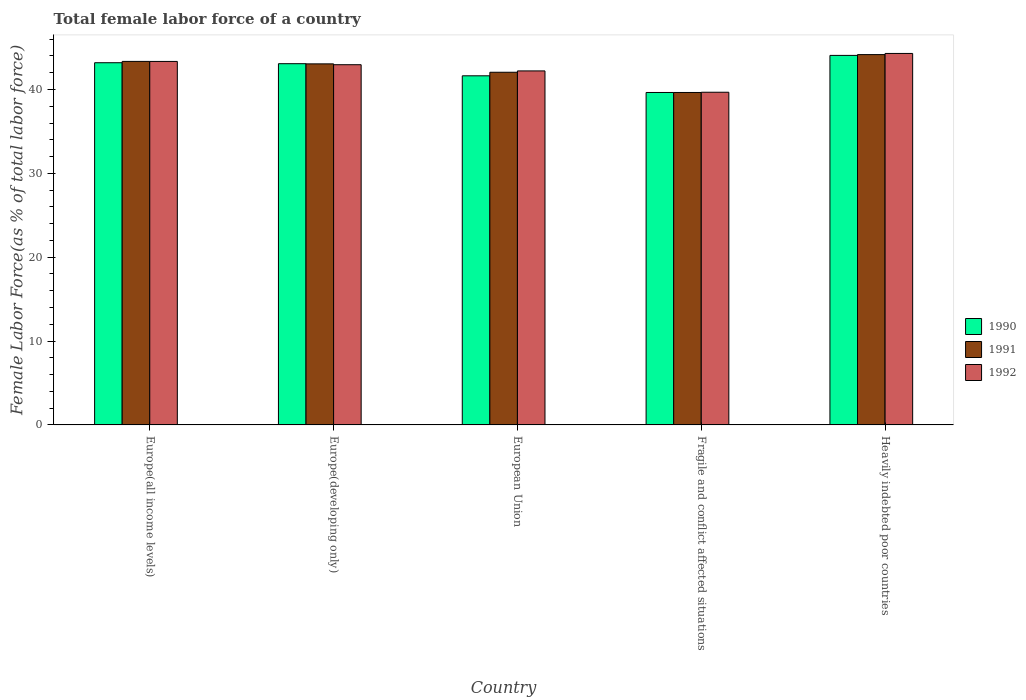How many groups of bars are there?
Give a very brief answer. 5. Are the number of bars per tick equal to the number of legend labels?
Offer a terse response. Yes. Are the number of bars on each tick of the X-axis equal?
Give a very brief answer. Yes. What is the label of the 5th group of bars from the left?
Ensure brevity in your answer.  Heavily indebted poor countries. What is the percentage of female labor force in 1990 in Fragile and conflict affected situations?
Your answer should be very brief. 39.65. Across all countries, what is the maximum percentage of female labor force in 1992?
Make the answer very short. 44.3. Across all countries, what is the minimum percentage of female labor force in 1992?
Ensure brevity in your answer.  39.67. In which country was the percentage of female labor force in 1992 maximum?
Offer a terse response. Heavily indebted poor countries. In which country was the percentage of female labor force in 1990 minimum?
Your answer should be very brief. Fragile and conflict affected situations. What is the total percentage of female labor force in 1990 in the graph?
Give a very brief answer. 211.62. What is the difference between the percentage of female labor force in 1990 in Fragile and conflict affected situations and that in Heavily indebted poor countries?
Keep it short and to the point. -4.42. What is the difference between the percentage of female labor force in 1992 in Fragile and conflict affected situations and the percentage of female labor force in 1990 in Europe(developing only)?
Keep it short and to the point. -3.41. What is the average percentage of female labor force in 1992 per country?
Your answer should be compact. 42.5. What is the difference between the percentage of female labor force of/in 1992 and percentage of female labor force of/in 1991 in European Union?
Provide a short and direct response. 0.16. What is the ratio of the percentage of female labor force in 1991 in Europe(developing only) to that in European Union?
Your answer should be compact. 1.02. Is the percentage of female labor force in 1990 in Europe(developing only) less than that in European Union?
Keep it short and to the point. No. Is the difference between the percentage of female labor force in 1992 in Europe(all income levels) and European Union greater than the difference between the percentage of female labor force in 1991 in Europe(all income levels) and European Union?
Offer a very short reply. No. What is the difference between the highest and the second highest percentage of female labor force in 1990?
Your answer should be compact. -0.12. What is the difference between the highest and the lowest percentage of female labor force in 1990?
Offer a very short reply. 4.42. Is the sum of the percentage of female labor force in 1991 in Europe(developing only) and European Union greater than the maximum percentage of female labor force in 1990 across all countries?
Make the answer very short. Yes. What does the 2nd bar from the right in Fragile and conflict affected situations represents?
Your answer should be compact. 1991. How many bars are there?
Give a very brief answer. 15. Are all the bars in the graph horizontal?
Provide a short and direct response. No. What is the difference between two consecutive major ticks on the Y-axis?
Give a very brief answer. 10. Does the graph contain any zero values?
Provide a short and direct response. No. Where does the legend appear in the graph?
Offer a terse response. Center right. How many legend labels are there?
Offer a very short reply. 3. How are the legend labels stacked?
Make the answer very short. Vertical. What is the title of the graph?
Provide a short and direct response. Total female labor force of a country. Does "1998" appear as one of the legend labels in the graph?
Your response must be concise. No. What is the label or title of the Y-axis?
Offer a very short reply. Female Labor Force(as % of total labor force). What is the Female Labor Force(as % of total labor force) of 1990 in Europe(all income levels)?
Your answer should be very brief. 43.2. What is the Female Labor Force(as % of total labor force) in 1991 in Europe(all income levels)?
Make the answer very short. 43.35. What is the Female Labor Force(as % of total labor force) in 1992 in Europe(all income levels)?
Provide a short and direct response. 43.35. What is the Female Labor Force(as % of total labor force) in 1990 in Europe(developing only)?
Your answer should be very brief. 43.08. What is the Female Labor Force(as % of total labor force) of 1991 in Europe(developing only)?
Offer a very short reply. 43.06. What is the Female Labor Force(as % of total labor force) of 1992 in Europe(developing only)?
Ensure brevity in your answer.  42.96. What is the Female Labor Force(as % of total labor force) of 1990 in European Union?
Provide a succinct answer. 41.63. What is the Female Labor Force(as % of total labor force) in 1991 in European Union?
Provide a succinct answer. 42.06. What is the Female Labor Force(as % of total labor force) of 1992 in European Union?
Offer a terse response. 42.22. What is the Female Labor Force(as % of total labor force) of 1990 in Fragile and conflict affected situations?
Offer a terse response. 39.65. What is the Female Labor Force(as % of total labor force) in 1991 in Fragile and conflict affected situations?
Your response must be concise. 39.65. What is the Female Labor Force(as % of total labor force) of 1992 in Fragile and conflict affected situations?
Your response must be concise. 39.67. What is the Female Labor Force(as % of total labor force) in 1990 in Heavily indebted poor countries?
Provide a succinct answer. 44.07. What is the Female Labor Force(as % of total labor force) of 1991 in Heavily indebted poor countries?
Make the answer very short. 44.16. What is the Female Labor Force(as % of total labor force) of 1992 in Heavily indebted poor countries?
Your answer should be very brief. 44.3. Across all countries, what is the maximum Female Labor Force(as % of total labor force) in 1990?
Keep it short and to the point. 44.07. Across all countries, what is the maximum Female Labor Force(as % of total labor force) in 1991?
Your answer should be compact. 44.16. Across all countries, what is the maximum Female Labor Force(as % of total labor force) of 1992?
Your answer should be compact. 44.3. Across all countries, what is the minimum Female Labor Force(as % of total labor force) of 1990?
Provide a short and direct response. 39.65. Across all countries, what is the minimum Female Labor Force(as % of total labor force) of 1991?
Your answer should be very brief. 39.65. Across all countries, what is the minimum Female Labor Force(as % of total labor force) in 1992?
Your answer should be very brief. 39.67. What is the total Female Labor Force(as % of total labor force) in 1990 in the graph?
Your answer should be very brief. 211.62. What is the total Female Labor Force(as % of total labor force) of 1991 in the graph?
Your response must be concise. 212.28. What is the total Female Labor Force(as % of total labor force) in 1992 in the graph?
Your response must be concise. 212.5. What is the difference between the Female Labor Force(as % of total labor force) in 1990 in Europe(all income levels) and that in Europe(developing only)?
Provide a succinct answer. 0.12. What is the difference between the Female Labor Force(as % of total labor force) of 1991 in Europe(all income levels) and that in Europe(developing only)?
Your response must be concise. 0.3. What is the difference between the Female Labor Force(as % of total labor force) of 1992 in Europe(all income levels) and that in Europe(developing only)?
Provide a short and direct response. 0.39. What is the difference between the Female Labor Force(as % of total labor force) in 1990 in Europe(all income levels) and that in European Union?
Offer a very short reply. 1.56. What is the difference between the Female Labor Force(as % of total labor force) of 1991 in Europe(all income levels) and that in European Union?
Make the answer very short. 1.3. What is the difference between the Female Labor Force(as % of total labor force) in 1992 in Europe(all income levels) and that in European Union?
Your answer should be compact. 1.13. What is the difference between the Female Labor Force(as % of total labor force) of 1990 in Europe(all income levels) and that in Fragile and conflict affected situations?
Keep it short and to the point. 3.55. What is the difference between the Female Labor Force(as % of total labor force) of 1991 in Europe(all income levels) and that in Fragile and conflict affected situations?
Your answer should be compact. 3.71. What is the difference between the Female Labor Force(as % of total labor force) of 1992 in Europe(all income levels) and that in Fragile and conflict affected situations?
Make the answer very short. 3.68. What is the difference between the Female Labor Force(as % of total labor force) of 1990 in Europe(all income levels) and that in Heavily indebted poor countries?
Your answer should be compact. -0.87. What is the difference between the Female Labor Force(as % of total labor force) in 1991 in Europe(all income levels) and that in Heavily indebted poor countries?
Keep it short and to the point. -0.81. What is the difference between the Female Labor Force(as % of total labor force) of 1992 in Europe(all income levels) and that in Heavily indebted poor countries?
Your answer should be compact. -0.95. What is the difference between the Female Labor Force(as % of total labor force) in 1990 in Europe(developing only) and that in European Union?
Keep it short and to the point. 1.45. What is the difference between the Female Labor Force(as % of total labor force) in 1992 in Europe(developing only) and that in European Union?
Your answer should be compact. 0.74. What is the difference between the Female Labor Force(as % of total labor force) of 1990 in Europe(developing only) and that in Fragile and conflict affected situations?
Ensure brevity in your answer.  3.43. What is the difference between the Female Labor Force(as % of total labor force) in 1991 in Europe(developing only) and that in Fragile and conflict affected situations?
Offer a very short reply. 3.41. What is the difference between the Female Labor Force(as % of total labor force) of 1992 in Europe(developing only) and that in Fragile and conflict affected situations?
Ensure brevity in your answer.  3.28. What is the difference between the Female Labor Force(as % of total labor force) of 1990 in Europe(developing only) and that in Heavily indebted poor countries?
Your answer should be compact. -0.99. What is the difference between the Female Labor Force(as % of total labor force) in 1991 in Europe(developing only) and that in Heavily indebted poor countries?
Your answer should be compact. -1.11. What is the difference between the Female Labor Force(as % of total labor force) of 1992 in Europe(developing only) and that in Heavily indebted poor countries?
Provide a succinct answer. -1.34. What is the difference between the Female Labor Force(as % of total labor force) in 1990 in European Union and that in Fragile and conflict affected situations?
Offer a very short reply. 1.99. What is the difference between the Female Labor Force(as % of total labor force) in 1991 in European Union and that in Fragile and conflict affected situations?
Your answer should be compact. 2.41. What is the difference between the Female Labor Force(as % of total labor force) in 1992 in European Union and that in Fragile and conflict affected situations?
Your response must be concise. 2.54. What is the difference between the Female Labor Force(as % of total labor force) in 1990 in European Union and that in Heavily indebted poor countries?
Your response must be concise. -2.43. What is the difference between the Female Labor Force(as % of total labor force) of 1991 in European Union and that in Heavily indebted poor countries?
Provide a short and direct response. -2.11. What is the difference between the Female Labor Force(as % of total labor force) of 1992 in European Union and that in Heavily indebted poor countries?
Ensure brevity in your answer.  -2.08. What is the difference between the Female Labor Force(as % of total labor force) in 1990 in Fragile and conflict affected situations and that in Heavily indebted poor countries?
Your answer should be very brief. -4.42. What is the difference between the Female Labor Force(as % of total labor force) of 1991 in Fragile and conflict affected situations and that in Heavily indebted poor countries?
Offer a terse response. -4.52. What is the difference between the Female Labor Force(as % of total labor force) of 1992 in Fragile and conflict affected situations and that in Heavily indebted poor countries?
Offer a terse response. -4.63. What is the difference between the Female Labor Force(as % of total labor force) of 1990 in Europe(all income levels) and the Female Labor Force(as % of total labor force) of 1991 in Europe(developing only)?
Your answer should be compact. 0.14. What is the difference between the Female Labor Force(as % of total labor force) of 1990 in Europe(all income levels) and the Female Labor Force(as % of total labor force) of 1992 in Europe(developing only)?
Ensure brevity in your answer.  0.24. What is the difference between the Female Labor Force(as % of total labor force) of 1991 in Europe(all income levels) and the Female Labor Force(as % of total labor force) of 1992 in Europe(developing only)?
Offer a very short reply. 0.4. What is the difference between the Female Labor Force(as % of total labor force) in 1990 in Europe(all income levels) and the Female Labor Force(as % of total labor force) in 1991 in European Union?
Provide a short and direct response. 1.14. What is the difference between the Female Labor Force(as % of total labor force) in 1990 in Europe(all income levels) and the Female Labor Force(as % of total labor force) in 1992 in European Union?
Offer a terse response. 0.98. What is the difference between the Female Labor Force(as % of total labor force) of 1991 in Europe(all income levels) and the Female Labor Force(as % of total labor force) of 1992 in European Union?
Your response must be concise. 1.13. What is the difference between the Female Labor Force(as % of total labor force) in 1990 in Europe(all income levels) and the Female Labor Force(as % of total labor force) in 1991 in Fragile and conflict affected situations?
Ensure brevity in your answer.  3.55. What is the difference between the Female Labor Force(as % of total labor force) in 1990 in Europe(all income levels) and the Female Labor Force(as % of total labor force) in 1992 in Fragile and conflict affected situations?
Offer a very short reply. 3.52. What is the difference between the Female Labor Force(as % of total labor force) in 1991 in Europe(all income levels) and the Female Labor Force(as % of total labor force) in 1992 in Fragile and conflict affected situations?
Offer a terse response. 3.68. What is the difference between the Female Labor Force(as % of total labor force) of 1990 in Europe(all income levels) and the Female Labor Force(as % of total labor force) of 1991 in Heavily indebted poor countries?
Provide a succinct answer. -0.97. What is the difference between the Female Labor Force(as % of total labor force) in 1990 in Europe(all income levels) and the Female Labor Force(as % of total labor force) in 1992 in Heavily indebted poor countries?
Offer a very short reply. -1.11. What is the difference between the Female Labor Force(as % of total labor force) in 1991 in Europe(all income levels) and the Female Labor Force(as % of total labor force) in 1992 in Heavily indebted poor countries?
Provide a short and direct response. -0.95. What is the difference between the Female Labor Force(as % of total labor force) of 1990 in Europe(developing only) and the Female Labor Force(as % of total labor force) of 1991 in European Union?
Your answer should be compact. 1.02. What is the difference between the Female Labor Force(as % of total labor force) in 1990 in Europe(developing only) and the Female Labor Force(as % of total labor force) in 1992 in European Union?
Give a very brief answer. 0.86. What is the difference between the Female Labor Force(as % of total labor force) of 1991 in Europe(developing only) and the Female Labor Force(as % of total labor force) of 1992 in European Union?
Offer a very short reply. 0.84. What is the difference between the Female Labor Force(as % of total labor force) of 1990 in Europe(developing only) and the Female Labor Force(as % of total labor force) of 1991 in Fragile and conflict affected situations?
Give a very brief answer. 3.43. What is the difference between the Female Labor Force(as % of total labor force) in 1990 in Europe(developing only) and the Female Labor Force(as % of total labor force) in 1992 in Fragile and conflict affected situations?
Ensure brevity in your answer.  3.41. What is the difference between the Female Labor Force(as % of total labor force) of 1991 in Europe(developing only) and the Female Labor Force(as % of total labor force) of 1992 in Fragile and conflict affected situations?
Make the answer very short. 3.38. What is the difference between the Female Labor Force(as % of total labor force) in 1990 in Europe(developing only) and the Female Labor Force(as % of total labor force) in 1991 in Heavily indebted poor countries?
Make the answer very short. -1.08. What is the difference between the Female Labor Force(as % of total labor force) in 1990 in Europe(developing only) and the Female Labor Force(as % of total labor force) in 1992 in Heavily indebted poor countries?
Your answer should be very brief. -1.22. What is the difference between the Female Labor Force(as % of total labor force) in 1991 in Europe(developing only) and the Female Labor Force(as % of total labor force) in 1992 in Heavily indebted poor countries?
Provide a succinct answer. -1.24. What is the difference between the Female Labor Force(as % of total labor force) in 1990 in European Union and the Female Labor Force(as % of total labor force) in 1991 in Fragile and conflict affected situations?
Ensure brevity in your answer.  1.99. What is the difference between the Female Labor Force(as % of total labor force) in 1990 in European Union and the Female Labor Force(as % of total labor force) in 1992 in Fragile and conflict affected situations?
Your answer should be compact. 1.96. What is the difference between the Female Labor Force(as % of total labor force) of 1991 in European Union and the Female Labor Force(as % of total labor force) of 1992 in Fragile and conflict affected situations?
Your response must be concise. 2.38. What is the difference between the Female Labor Force(as % of total labor force) of 1990 in European Union and the Female Labor Force(as % of total labor force) of 1991 in Heavily indebted poor countries?
Ensure brevity in your answer.  -2.53. What is the difference between the Female Labor Force(as % of total labor force) in 1990 in European Union and the Female Labor Force(as % of total labor force) in 1992 in Heavily indebted poor countries?
Your answer should be compact. -2.67. What is the difference between the Female Labor Force(as % of total labor force) in 1991 in European Union and the Female Labor Force(as % of total labor force) in 1992 in Heavily indebted poor countries?
Offer a very short reply. -2.24. What is the difference between the Female Labor Force(as % of total labor force) of 1990 in Fragile and conflict affected situations and the Female Labor Force(as % of total labor force) of 1991 in Heavily indebted poor countries?
Offer a terse response. -4.52. What is the difference between the Female Labor Force(as % of total labor force) of 1990 in Fragile and conflict affected situations and the Female Labor Force(as % of total labor force) of 1992 in Heavily indebted poor countries?
Offer a terse response. -4.66. What is the difference between the Female Labor Force(as % of total labor force) in 1991 in Fragile and conflict affected situations and the Female Labor Force(as % of total labor force) in 1992 in Heavily indebted poor countries?
Give a very brief answer. -4.65. What is the average Female Labor Force(as % of total labor force) of 1990 per country?
Offer a very short reply. 42.32. What is the average Female Labor Force(as % of total labor force) in 1991 per country?
Provide a succinct answer. 42.46. What is the average Female Labor Force(as % of total labor force) in 1992 per country?
Make the answer very short. 42.5. What is the difference between the Female Labor Force(as % of total labor force) of 1990 and Female Labor Force(as % of total labor force) of 1991 in Europe(all income levels)?
Your answer should be compact. -0.16. What is the difference between the Female Labor Force(as % of total labor force) of 1990 and Female Labor Force(as % of total labor force) of 1992 in Europe(all income levels)?
Keep it short and to the point. -0.15. What is the difference between the Female Labor Force(as % of total labor force) of 1991 and Female Labor Force(as % of total labor force) of 1992 in Europe(all income levels)?
Make the answer very short. 0. What is the difference between the Female Labor Force(as % of total labor force) of 1990 and Female Labor Force(as % of total labor force) of 1991 in Europe(developing only)?
Your response must be concise. 0.02. What is the difference between the Female Labor Force(as % of total labor force) in 1990 and Female Labor Force(as % of total labor force) in 1992 in Europe(developing only)?
Your answer should be very brief. 0.12. What is the difference between the Female Labor Force(as % of total labor force) of 1991 and Female Labor Force(as % of total labor force) of 1992 in Europe(developing only)?
Your answer should be very brief. 0.1. What is the difference between the Female Labor Force(as % of total labor force) in 1990 and Female Labor Force(as % of total labor force) in 1991 in European Union?
Provide a short and direct response. -0.42. What is the difference between the Female Labor Force(as % of total labor force) of 1990 and Female Labor Force(as % of total labor force) of 1992 in European Union?
Give a very brief answer. -0.58. What is the difference between the Female Labor Force(as % of total labor force) in 1991 and Female Labor Force(as % of total labor force) in 1992 in European Union?
Provide a succinct answer. -0.16. What is the difference between the Female Labor Force(as % of total labor force) in 1990 and Female Labor Force(as % of total labor force) in 1991 in Fragile and conflict affected situations?
Your answer should be very brief. -0. What is the difference between the Female Labor Force(as % of total labor force) in 1990 and Female Labor Force(as % of total labor force) in 1992 in Fragile and conflict affected situations?
Give a very brief answer. -0.03. What is the difference between the Female Labor Force(as % of total labor force) of 1991 and Female Labor Force(as % of total labor force) of 1992 in Fragile and conflict affected situations?
Ensure brevity in your answer.  -0.03. What is the difference between the Female Labor Force(as % of total labor force) of 1990 and Female Labor Force(as % of total labor force) of 1991 in Heavily indebted poor countries?
Offer a very short reply. -0.1. What is the difference between the Female Labor Force(as % of total labor force) in 1990 and Female Labor Force(as % of total labor force) in 1992 in Heavily indebted poor countries?
Provide a succinct answer. -0.23. What is the difference between the Female Labor Force(as % of total labor force) in 1991 and Female Labor Force(as % of total labor force) in 1992 in Heavily indebted poor countries?
Your answer should be very brief. -0.14. What is the ratio of the Female Labor Force(as % of total labor force) of 1990 in Europe(all income levels) to that in Europe(developing only)?
Ensure brevity in your answer.  1. What is the ratio of the Female Labor Force(as % of total labor force) of 1991 in Europe(all income levels) to that in Europe(developing only)?
Your answer should be compact. 1.01. What is the ratio of the Female Labor Force(as % of total labor force) of 1992 in Europe(all income levels) to that in Europe(developing only)?
Make the answer very short. 1.01. What is the ratio of the Female Labor Force(as % of total labor force) of 1990 in Europe(all income levels) to that in European Union?
Make the answer very short. 1.04. What is the ratio of the Female Labor Force(as % of total labor force) of 1991 in Europe(all income levels) to that in European Union?
Your response must be concise. 1.03. What is the ratio of the Female Labor Force(as % of total labor force) in 1992 in Europe(all income levels) to that in European Union?
Make the answer very short. 1.03. What is the ratio of the Female Labor Force(as % of total labor force) in 1990 in Europe(all income levels) to that in Fragile and conflict affected situations?
Provide a succinct answer. 1.09. What is the ratio of the Female Labor Force(as % of total labor force) in 1991 in Europe(all income levels) to that in Fragile and conflict affected situations?
Make the answer very short. 1.09. What is the ratio of the Female Labor Force(as % of total labor force) of 1992 in Europe(all income levels) to that in Fragile and conflict affected situations?
Offer a very short reply. 1.09. What is the ratio of the Female Labor Force(as % of total labor force) in 1990 in Europe(all income levels) to that in Heavily indebted poor countries?
Provide a short and direct response. 0.98. What is the ratio of the Female Labor Force(as % of total labor force) of 1991 in Europe(all income levels) to that in Heavily indebted poor countries?
Your answer should be compact. 0.98. What is the ratio of the Female Labor Force(as % of total labor force) in 1992 in Europe(all income levels) to that in Heavily indebted poor countries?
Give a very brief answer. 0.98. What is the ratio of the Female Labor Force(as % of total labor force) in 1990 in Europe(developing only) to that in European Union?
Make the answer very short. 1.03. What is the ratio of the Female Labor Force(as % of total labor force) in 1991 in Europe(developing only) to that in European Union?
Make the answer very short. 1.02. What is the ratio of the Female Labor Force(as % of total labor force) in 1992 in Europe(developing only) to that in European Union?
Make the answer very short. 1.02. What is the ratio of the Female Labor Force(as % of total labor force) in 1990 in Europe(developing only) to that in Fragile and conflict affected situations?
Your response must be concise. 1.09. What is the ratio of the Female Labor Force(as % of total labor force) in 1991 in Europe(developing only) to that in Fragile and conflict affected situations?
Provide a short and direct response. 1.09. What is the ratio of the Female Labor Force(as % of total labor force) of 1992 in Europe(developing only) to that in Fragile and conflict affected situations?
Ensure brevity in your answer.  1.08. What is the ratio of the Female Labor Force(as % of total labor force) in 1990 in Europe(developing only) to that in Heavily indebted poor countries?
Ensure brevity in your answer.  0.98. What is the ratio of the Female Labor Force(as % of total labor force) in 1992 in Europe(developing only) to that in Heavily indebted poor countries?
Provide a short and direct response. 0.97. What is the ratio of the Female Labor Force(as % of total labor force) of 1990 in European Union to that in Fragile and conflict affected situations?
Ensure brevity in your answer.  1.05. What is the ratio of the Female Labor Force(as % of total labor force) of 1991 in European Union to that in Fragile and conflict affected situations?
Give a very brief answer. 1.06. What is the ratio of the Female Labor Force(as % of total labor force) in 1992 in European Union to that in Fragile and conflict affected situations?
Provide a short and direct response. 1.06. What is the ratio of the Female Labor Force(as % of total labor force) of 1990 in European Union to that in Heavily indebted poor countries?
Offer a terse response. 0.94. What is the ratio of the Female Labor Force(as % of total labor force) in 1991 in European Union to that in Heavily indebted poor countries?
Your response must be concise. 0.95. What is the ratio of the Female Labor Force(as % of total labor force) in 1992 in European Union to that in Heavily indebted poor countries?
Offer a very short reply. 0.95. What is the ratio of the Female Labor Force(as % of total labor force) of 1990 in Fragile and conflict affected situations to that in Heavily indebted poor countries?
Keep it short and to the point. 0.9. What is the ratio of the Female Labor Force(as % of total labor force) of 1991 in Fragile and conflict affected situations to that in Heavily indebted poor countries?
Offer a terse response. 0.9. What is the ratio of the Female Labor Force(as % of total labor force) in 1992 in Fragile and conflict affected situations to that in Heavily indebted poor countries?
Offer a terse response. 0.9. What is the difference between the highest and the second highest Female Labor Force(as % of total labor force) of 1990?
Give a very brief answer. 0.87. What is the difference between the highest and the second highest Female Labor Force(as % of total labor force) in 1991?
Give a very brief answer. 0.81. What is the difference between the highest and the second highest Female Labor Force(as % of total labor force) of 1992?
Provide a succinct answer. 0.95. What is the difference between the highest and the lowest Female Labor Force(as % of total labor force) in 1990?
Offer a terse response. 4.42. What is the difference between the highest and the lowest Female Labor Force(as % of total labor force) in 1991?
Provide a short and direct response. 4.52. What is the difference between the highest and the lowest Female Labor Force(as % of total labor force) in 1992?
Give a very brief answer. 4.63. 